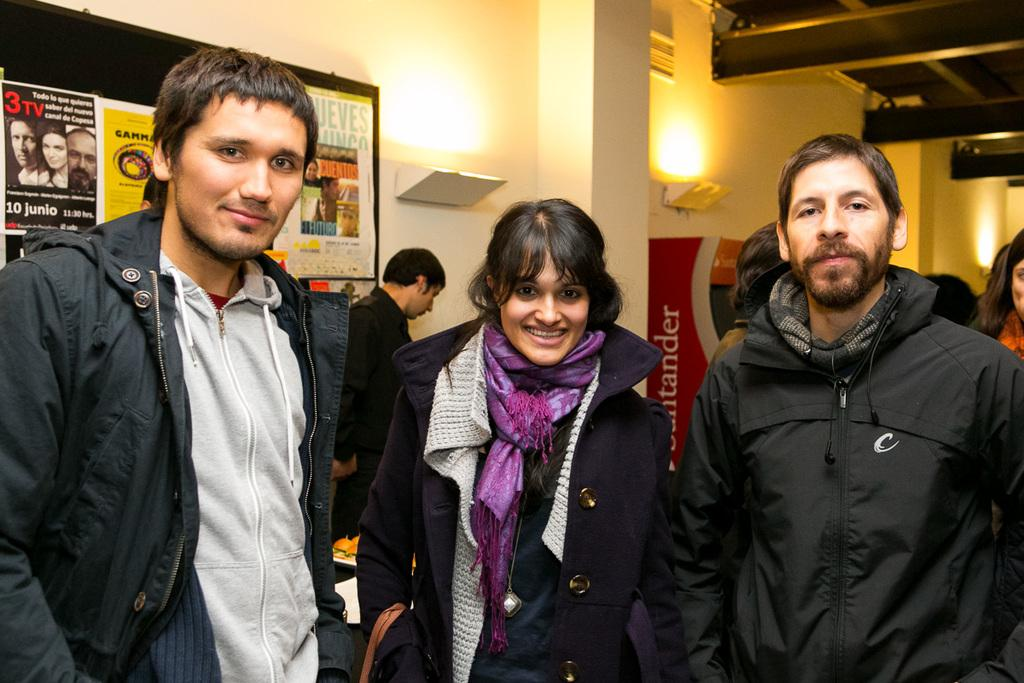What can be seen in the image involving people? There are people standing in the image. What type of objects with text are present in the image? There are posters with text in the image. What can be seen providing illumination in the image? There are lights visible in the image. What architectural feature is present in the image? There is a pillar in the image. What type of ball is being used by the father in the image? There is no ball or father present in the image. 